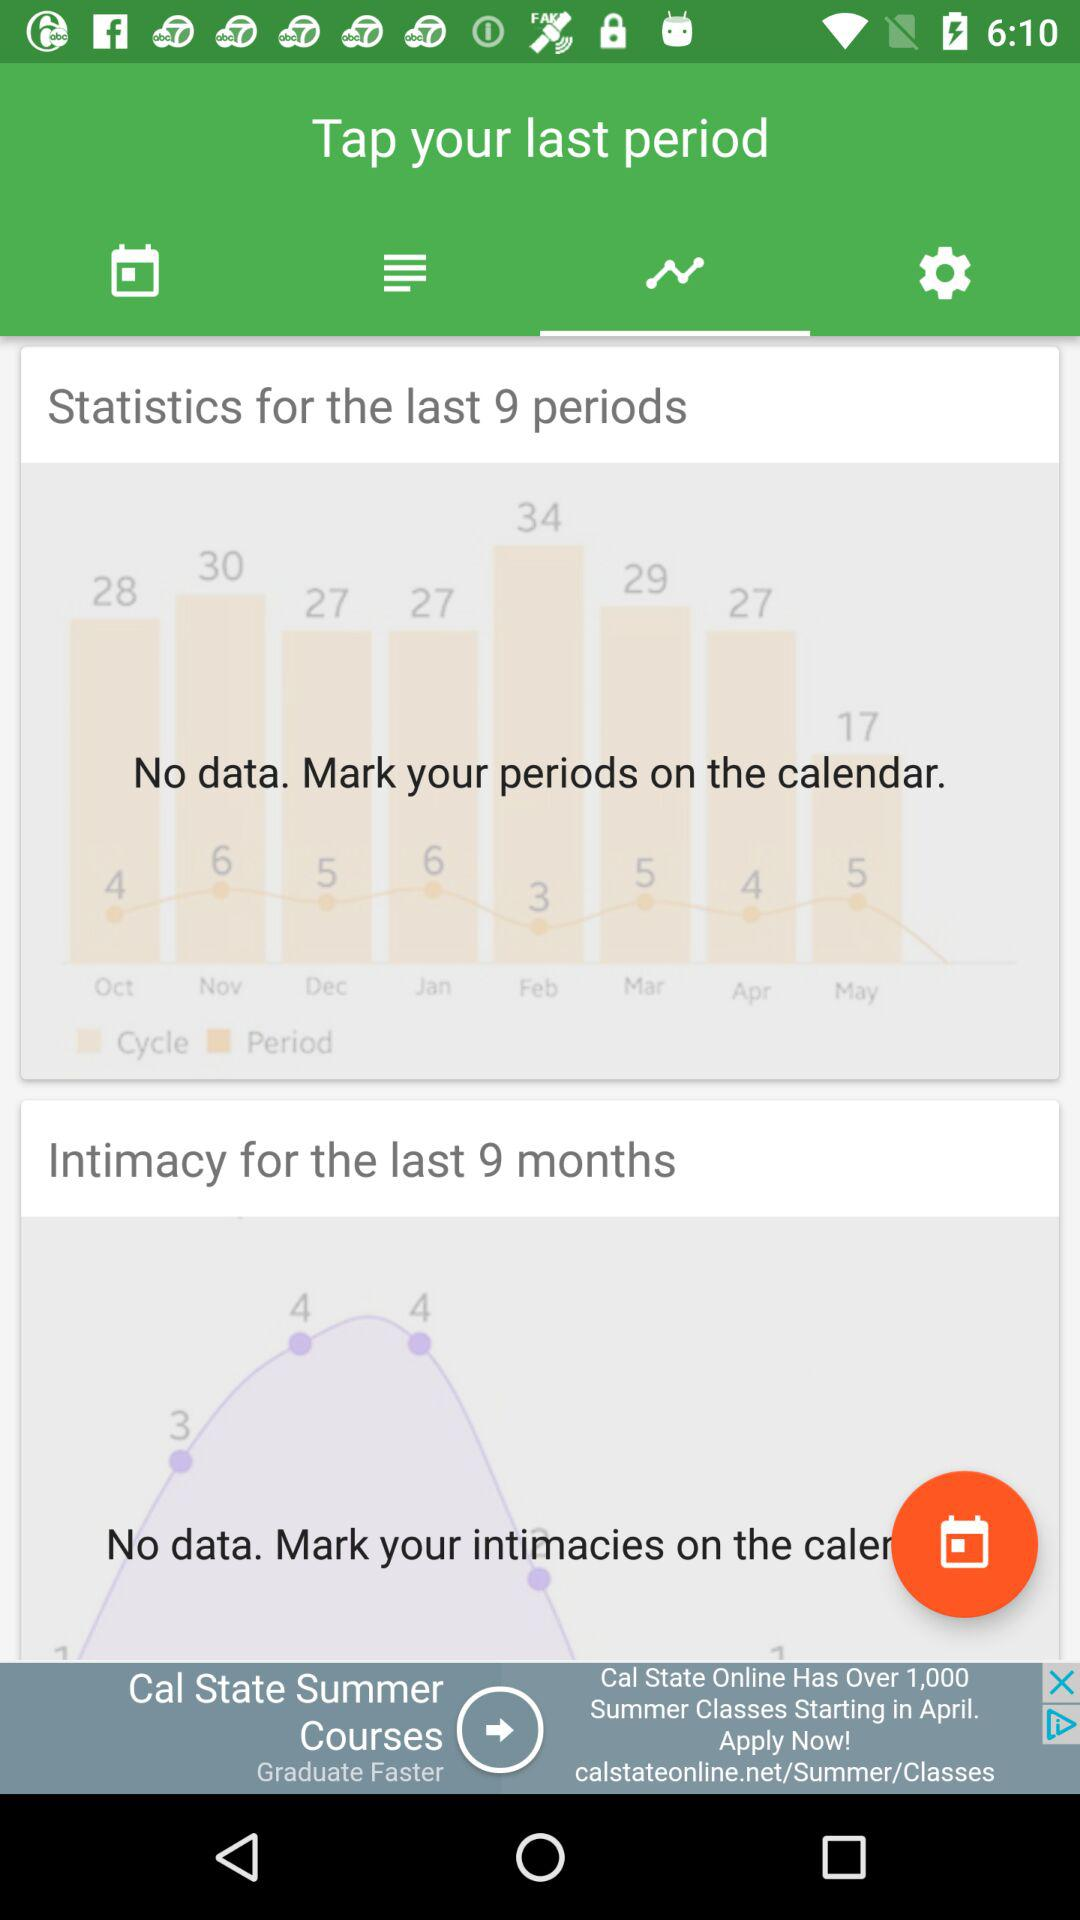How many data points are there in the intimacy graph?
Answer the question using a single word or phrase. 0 